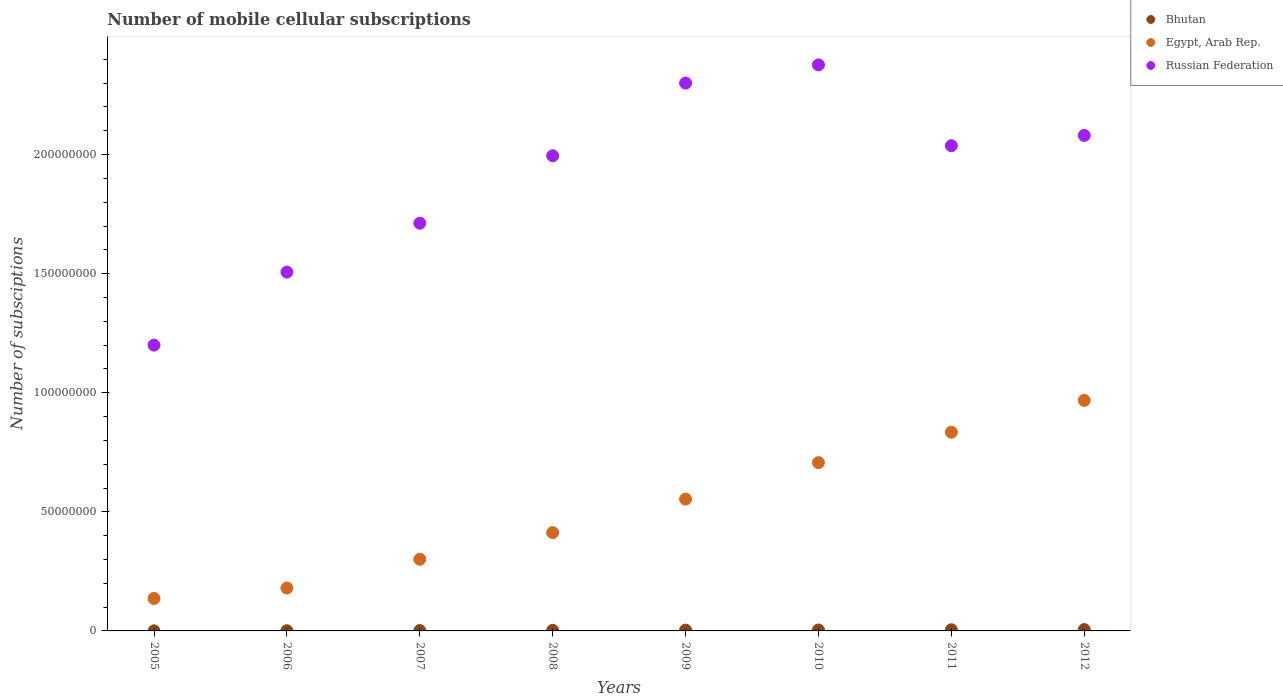Is the number of dotlines equal to the number of legend labels?
Provide a short and direct response. Yes. What is the number of mobile cellular subscriptions in Egypt, Arab Rep. in 2009?
Give a very brief answer. 5.54e+07. Across all years, what is the maximum number of mobile cellular subscriptions in Egypt, Arab Rep.?
Your response must be concise. 9.68e+07. Across all years, what is the minimum number of mobile cellular subscriptions in Bhutan?
Provide a short and direct response. 3.60e+04. In which year was the number of mobile cellular subscriptions in Egypt, Arab Rep. maximum?
Offer a terse response. 2012. In which year was the number of mobile cellular subscriptions in Egypt, Arab Rep. minimum?
Ensure brevity in your answer.  2005. What is the total number of mobile cellular subscriptions in Russian Federation in the graph?
Offer a terse response. 1.52e+09. What is the difference between the number of mobile cellular subscriptions in Russian Federation in 2005 and that in 2011?
Your response must be concise. -8.38e+07. What is the difference between the number of mobile cellular subscriptions in Egypt, Arab Rep. in 2006 and the number of mobile cellular subscriptions in Russian Federation in 2012?
Keep it short and to the point. -1.90e+08. What is the average number of mobile cellular subscriptions in Egypt, Arab Rep. per year?
Make the answer very short. 5.12e+07. In the year 2006, what is the difference between the number of mobile cellular subscriptions in Russian Federation and number of mobile cellular subscriptions in Bhutan?
Offer a terse response. 1.51e+08. What is the ratio of the number of mobile cellular subscriptions in Egypt, Arab Rep. in 2006 to that in 2008?
Your answer should be compact. 0.44. What is the difference between the highest and the second highest number of mobile cellular subscriptions in Russian Federation?
Your answer should be very brief. 7.64e+06. What is the difference between the highest and the lowest number of mobile cellular subscriptions in Russian Federation?
Offer a very short reply. 1.18e+08. Is the number of mobile cellular subscriptions in Egypt, Arab Rep. strictly greater than the number of mobile cellular subscriptions in Russian Federation over the years?
Ensure brevity in your answer.  No. Is the number of mobile cellular subscriptions in Russian Federation strictly less than the number of mobile cellular subscriptions in Egypt, Arab Rep. over the years?
Your answer should be compact. No. How many dotlines are there?
Offer a terse response. 3. What is the difference between two consecutive major ticks on the Y-axis?
Keep it short and to the point. 5.00e+07. Does the graph contain any zero values?
Provide a short and direct response. No. Does the graph contain grids?
Provide a short and direct response. No. Where does the legend appear in the graph?
Ensure brevity in your answer.  Top right. How are the legend labels stacked?
Offer a terse response. Vertical. What is the title of the graph?
Your answer should be very brief. Number of mobile cellular subscriptions. Does "Venezuela" appear as one of the legend labels in the graph?
Make the answer very short. No. What is the label or title of the X-axis?
Your answer should be very brief. Years. What is the label or title of the Y-axis?
Give a very brief answer. Number of subsciptions. What is the Number of subsciptions of Bhutan in 2005?
Offer a very short reply. 3.60e+04. What is the Number of subsciptions of Egypt, Arab Rep. in 2005?
Offer a very short reply. 1.36e+07. What is the Number of subsciptions in Russian Federation in 2005?
Provide a succinct answer. 1.20e+08. What is the Number of subsciptions in Bhutan in 2006?
Offer a terse response. 8.21e+04. What is the Number of subsciptions in Egypt, Arab Rep. in 2006?
Your answer should be very brief. 1.80e+07. What is the Number of subsciptions of Russian Federation in 2006?
Offer a terse response. 1.51e+08. What is the Number of subsciptions in Bhutan in 2007?
Ensure brevity in your answer.  1.49e+05. What is the Number of subsciptions of Egypt, Arab Rep. in 2007?
Your answer should be compact. 3.01e+07. What is the Number of subsciptions of Russian Federation in 2007?
Give a very brief answer. 1.71e+08. What is the Number of subsciptions of Bhutan in 2008?
Give a very brief answer. 2.53e+05. What is the Number of subsciptions of Egypt, Arab Rep. in 2008?
Make the answer very short. 4.13e+07. What is the Number of subsciptions in Russian Federation in 2008?
Keep it short and to the point. 2.00e+08. What is the Number of subsciptions in Bhutan in 2009?
Offer a terse response. 3.39e+05. What is the Number of subsciptions of Egypt, Arab Rep. in 2009?
Your response must be concise. 5.54e+07. What is the Number of subsciptions of Russian Federation in 2009?
Ensure brevity in your answer.  2.30e+08. What is the Number of subsciptions in Bhutan in 2010?
Make the answer very short. 3.94e+05. What is the Number of subsciptions of Egypt, Arab Rep. in 2010?
Offer a terse response. 7.07e+07. What is the Number of subsciptions of Russian Federation in 2010?
Provide a short and direct response. 2.38e+08. What is the Number of subsciptions in Bhutan in 2011?
Ensure brevity in your answer.  4.84e+05. What is the Number of subsciptions in Egypt, Arab Rep. in 2011?
Provide a succinct answer. 8.34e+07. What is the Number of subsciptions in Russian Federation in 2011?
Offer a terse response. 2.04e+08. What is the Number of subsciptions in Bhutan in 2012?
Make the answer very short. 5.61e+05. What is the Number of subsciptions of Egypt, Arab Rep. in 2012?
Offer a very short reply. 9.68e+07. What is the Number of subsciptions in Russian Federation in 2012?
Provide a succinct answer. 2.08e+08. Across all years, what is the maximum Number of subsciptions in Bhutan?
Give a very brief answer. 5.61e+05. Across all years, what is the maximum Number of subsciptions in Egypt, Arab Rep.?
Offer a very short reply. 9.68e+07. Across all years, what is the maximum Number of subsciptions of Russian Federation?
Offer a terse response. 2.38e+08. Across all years, what is the minimum Number of subsciptions of Bhutan?
Give a very brief answer. 3.60e+04. Across all years, what is the minimum Number of subsciptions in Egypt, Arab Rep.?
Keep it short and to the point. 1.36e+07. Across all years, what is the minimum Number of subsciptions in Russian Federation?
Keep it short and to the point. 1.20e+08. What is the total Number of subsciptions in Bhutan in the graph?
Your answer should be very brief. 2.30e+06. What is the total Number of subsciptions in Egypt, Arab Rep. in the graph?
Offer a terse response. 4.09e+08. What is the total Number of subsciptions in Russian Federation in the graph?
Offer a very short reply. 1.52e+09. What is the difference between the Number of subsciptions of Bhutan in 2005 and that in 2006?
Your answer should be very brief. -4.61e+04. What is the difference between the Number of subsciptions in Egypt, Arab Rep. in 2005 and that in 2006?
Offer a very short reply. -4.37e+06. What is the difference between the Number of subsciptions in Russian Federation in 2005 and that in 2006?
Provide a succinct answer. -3.07e+07. What is the difference between the Number of subsciptions of Bhutan in 2005 and that in 2007?
Provide a short and direct response. -1.13e+05. What is the difference between the Number of subsciptions in Egypt, Arab Rep. in 2005 and that in 2007?
Ensure brevity in your answer.  -1.65e+07. What is the difference between the Number of subsciptions of Russian Federation in 2005 and that in 2007?
Keep it short and to the point. -5.12e+07. What is the difference between the Number of subsciptions in Bhutan in 2005 and that in 2008?
Your answer should be compact. -2.17e+05. What is the difference between the Number of subsciptions in Egypt, Arab Rep. in 2005 and that in 2008?
Your answer should be compact. -2.77e+07. What is the difference between the Number of subsciptions in Russian Federation in 2005 and that in 2008?
Provide a short and direct response. -7.95e+07. What is the difference between the Number of subsciptions in Bhutan in 2005 and that in 2009?
Provide a short and direct response. -3.03e+05. What is the difference between the Number of subsciptions of Egypt, Arab Rep. in 2005 and that in 2009?
Provide a succinct answer. -4.17e+07. What is the difference between the Number of subsciptions of Russian Federation in 2005 and that in 2009?
Your response must be concise. -1.10e+08. What is the difference between the Number of subsciptions in Bhutan in 2005 and that in 2010?
Your answer should be compact. -3.58e+05. What is the difference between the Number of subsciptions of Egypt, Arab Rep. in 2005 and that in 2010?
Your response must be concise. -5.70e+07. What is the difference between the Number of subsciptions in Russian Federation in 2005 and that in 2010?
Keep it short and to the point. -1.18e+08. What is the difference between the Number of subsciptions in Bhutan in 2005 and that in 2011?
Provide a short and direct response. -4.48e+05. What is the difference between the Number of subsciptions in Egypt, Arab Rep. in 2005 and that in 2011?
Your answer should be very brief. -6.98e+07. What is the difference between the Number of subsciptions of Russian Federation in 2005 and that in 2011?
Ensure brevity in your answer.  -8.38e+07. What is the difference between the Number of subsciptions of Bhutan in 2005 and that in 2012?
Provide a succinct answer. -5.25e+05. What is the difference between the Number of subsciptions of Egypt, Arab Rep. in 2005 and that in 2012?
Your response must be concise. -8.32e+07. What is the difference between the Number of subsciptions of Russian Federation in 2005 and that in 2012?
Give a very brief answer. -8.81e+07. What is the difference between the Number of subsciptions in Bhutan in 2006 and that in 2007?
Provide a short and direct response. -6.74e+04. What is the difference between the Number of subsciptions in Egypt, Arab Rep. in 2006 and that in 2007?
Make the answer very short. -1.21e+07. What is the difference between the Number of subsciptions of Russian Federation in 2006 and that in 2007?
Provide a short and direct response. -2.05e+07. What is the difference between the Number of subsciptions in Bhutan in 2006 and that in 2008?
Give a very brief answer. -1.71e+05. What is the difference between the Number of subsciptions of Egypt, Arab Rep. in 2006 and that in 2008?
Keep it short and to the point. -2.33e+07. What is the difference between the Number of subsciptions of Russian Federation in 2006 and that in 2008?
Give a very brief answer. -4.88e+07. What is the difference between the Number of subsciptions in Bhutan in 2006 and that in 2009?
Give a very brief answer. -2.57e+05. What is the difference between the Number of subsciptions of Egypt, Arab Rep. in 2006 and that in 2009?
Offer a very short reply. -3.74e+07. What is the difference between the Number of subsciptions in Russian Federation in 2006 and that in 2009?
Your answer should be very brief. -7.94e+07. What is the difference between the Number of subsciptions of Bhutan in 2006 and that in 2010?
Keep it short and to the point. -3.12e+05. What is the difference between the Number of subsciptions of Egypt, Arab Rep. in 2006 and that in 2010?
Offer a terse response. -5.27e+07. What is the difference between the Number of subsciptions in Russian Federation in 2006 and that in 2010?
Keep it short and to the point. -8.70e+07. What is the difference between the Number of subsciptions of Bhutan in 2006 and that in 2011?
Give a very brief answer. -4.02e+05. What is the difference between the Number of subsciptions of Egypt, Arab Rep. in 2006 and that in 2011?
Your answer should be compact. -6.54e+07. What is the difference between the Number of subsciptions in Russian Federation in 2006 and that in 2011?
Ensure brevity in your answer.  -5.31e+07. What is the difference between the Number of subsciptions in Bhutan in 2006 and that in 2012?
Provide a succinct answer. -4.79e+05. What is the difference between the Number of subsciptions of Egypt, Arab Rep. in 2006 and that in 2012?
Your answer should be very brief. -7.88e+07. What is the difference between the Number of subsciptions in Russian Federation in 2006 and that in 2012?
Provide a succinct answer. -5.74e+07. What is the difference between the Number of subsciptions in Bhutan in 2007 and that in 2008?
Make the answer very short. -1.04e+05. What is the difference between the Number of subsciptions of Egypt, Arab Rep. in 2007 and that in 2008?
Make the answer very short. -1.12e+07. What is the difference between the Number of subsciptions in Russian Federation in 2007 and that in 2008?
Your response must be concise. -2.83e+07. What is the difference between the Number of subsciptions of Bhutan in 2007 and that in 2009?
Offer a very short reply. -1.89e+05. What is the difference between the Number of subsciptions of Egypt, Arab Rep. in 2007 and that in 2009?
Give a very brief answer. -2.53e+07. What is the difference between the Number of subsciptions in Russian Federation in 2007 and that in 2009?
Provide a short and direct response. -5.88e+07. What is the difference between the Number of subsciptions of Bhutan in 2007 and that in 2010?
Provide a succinct answer. -2.45e+05. What is the difference between the Number of subsciptions of Egypt, Arab Rep. in 2007 and that in 2010?
Your answer should be compact. -4.06e+07. What is the difference between the Number of subsciptions of Russian Federation in 2007 and that in 2010?
Offer a terse response. -6.65e+07. What is the difference between the Number of subsciptions of Bhutan in 2007 and that in 2011?
Offer a terse response. -3.35e+05. What is the difference between the Number of subsciptions in Egypt, Arab Rep. in 2007 and that in 2011?
Offer a terse response. -5.33e+07. What is the difference between the Number of subsciptions of Russian Federation in 2007 and that in 2011?
Your answer should be very brief. -3.26e+07. What is the difference between the Number of subsciptions in Bhutan in 2007 and that in 2012?
Provide a short and direct response. -4.11e+05. What is the difference between the Number of subsciptions of Egypt, Arab Rep. in 2007 and that in 2012?
Give a very brief answer. -6.67e+07. What is the difference between the Number of subsciptions of Russian Federation in 2007 and that in 2012?
Keep it short and to the point. -3.69e+07. What is the difference between the Number of subsciptions of Bhutan in 2008 and that in 2009?
Make the answer very short. -8.55e+04. What is the difference between the Number of subsciptions in Egypt, Arab Rep. in 2008 and that in 2009?
Ensure brevity in your answer.  -1.41e+07. What is the difference between the Number of subsciptions of Russian Federation in 2008 and that in 2009?
Offer a terse response. -3.05e+07. What is the difference between the Number of subsciptions of Bhutan in 2008 and that in 2010?
Ensure brevity in your answer.  -1.41e+05. What is the difference between the Number of subsciptions in Egypt, Arab Rep. in 2008 and that in 2010?
Make the answer very short. -2.94e+07. What is the difference between the Number of subsciptions in Russian Federation in 2008 and that in 2010?
Offer a terse response. -3.82e+07. What is the difference between the Number of subsciptions in Bhutan in 2008 and that in 2011?
Make the answer very short. -2.31e+05. What is the difference between the Number of subsciptions in Egypt, Arab Rep. in 2008 and that in 2011?
Make the answer very short. -4.21e+07. What is the difference between the Number of subsciptions of Russian Federation in 2008 and that in 2011?
Offer a terse response. -4.23e+06. What is the difference between the Number of subsciptions in Bhutan in 2008 and that in 2012?
Your response must be concise. -3.07e+05. What is the difference between the Number of subsciptions of Egypt, Arab Rep. in 2008 and that in 2012?
Provide a succinct answer. -5.55e+07. What is the difference between the Number of subsciptions in Russian Federation in 2008 and that in 2012?
Ensure brevity in your answer.  -8.54e+06. What is the difference between the Number of subsciptions of Bhutan in 2009 and that in 2010?
Offer a terse response. -5.54e+04. What is the difference between the Number of subsciptions of Egypt, Arab Rep. in 2009 and that in 2010?
Ensure brevity in your answer.  -1.53e+07. What is the difference between the Number of subsciptions in Russian Federation in 2009 and that in 2010?
Ensure brevity in your answer.  -7.64e+06. What is the difference between the Number of subsciptions of Bhutan in 2009 and that in 2011?
Keep it short and to the point. -1.45e+05. What is the difference between the Number of subsciptions of Egypt, Arab Rep. in 2009 and that in 2011?
Provide a succinct answer. -2.81e+07. What is the difference between the Number of subsciptions of Russian Federation in 2009 and that in 2011?
Your answer should be compact. 2.63e+07. What is the difference between the Number of subsciptions of Bhutan in 2009 and that in 2012?
Give a very brief answer. -2.22e+05. What is the difference between the Number of subsciptions in Egypt, Arab Rep. in 2009 and that in 2012?
Your answer should be very brief. -4.14e+07. What is the difference between the Number of subsciptions of Russian Federation in 2009 and that in 2012?
Your answer should be very brief. 2.20e+07. What is the difference between the Number of subsciptions of Bhutan in 2010 and that in 2011?
Give a very brief answer. -8.99e+04. What is the difference between the Number of subsciptions of Egypt, Arab Rep. in 2010 and that in 2011?
Your answer should be compact. -1.28e+07. What is the difference between the Number of subsciptions in Russian Federation in 2010 and that in 2011?
Your response must be concise. 3.39e+07. What is the difference between the Number of subsciptions of Bhutan in 2010 and that in 2012?
Your answer should be very brief. -1.67e+05. What is the difference between the Number of subsciptions in Egypt, Arab Rep. in 2010 and that in 2012?
Offer a very short reply. -2.61e+07. What is the difference between the Number of subsciptions of Russian Federation in 2010 and that in 2012?
Keep it short and to the point. 2.96e+07. What is the difference between the Number of subsciptions in Bhutan in 2011 and that in 2012?
Keep it short and to the point. -7.67e+04. What is the difference between the Number of subsciptions of Egypt, Arab Rep. in 2011 and that in 2012?
Your answer should be very brief. -1.34e+07. What is the difference between the Number of subsciptions of Russian Federation in 2011 and that in 2012?
Provide a short and direct response. -4.31e+06. What is the difference between the Number of subsciptions of Bhutan in 2005 and the Number of subsciptions of Egypt, Arab Rep. in 2006?
Provide a succinct answer. -1.80e+07. What is the difference between the Number of subsciptions of Bhutan in 2005 and the Number of subsciptions of Russian Federation in 2006?
Give a very brief answer. -1.51e+08. What is the difference between the Number of subsciptions of Egypt, Arab Rep. in 2005 and the Number of subsciptions of Russian Federation in 2006?
Offer a terse response. -1.37e+08. What is the difference between the Number of subsciptions in Bhutan in 2005 and the Number of subsciptions in Egypt, Arab Rep. in 2007?
Make the answer very short. -3.01e+07. What is the difference between the Number of subsciptions of Bhutan in 2005 and the Number of subsciptions of Russian Federation in 2007?
Ensure brevity in your answer.  -1.71e+08. What is the difference between the Number of subsciptions in Egypt, Arab Rep. in 2005 and the Number of subsciptions in Russian Federation in 2007?
Your answer should be compact. -1.58e+08. What is the difference between the Number of subsciptions in Bhutan in 2005 and the Number of subsciptions in Egypt, Arab Rep. in 2008?
Provide a succinct answer. -4.13e+07. What is the difference between the Number of subsciptions of Bhutan in 2005 and the Number of subsciptions of Russian Federation in 2008?
Your answer should be compact. -1.99e+08. What is the difference between the Number of subsciptions of Egypt, Arab Rep. in 2005 and the Number of subsciptions of Russian Federation in 2008?
Provide a succinct answer. -1.86e+08. What is the difference between the Number of subsciptions of Bhutan in 2005 and the Number of subsciptions of Egypt, Arab Rep. in 2009?
Provide a succinct answer. -5.53e+07. What is the difference between the Number of subsciptions of Bhutan in 2005 and the Number of subsciptions of Russian Federation in 2009?
Ensure brevity in your answer.  -2.30e+08. What is the difference between the Number of subsciptions in Egypt, Arab Rep. in 2005 and the Number of subsciptions in Russian Federation in 2009?
Your answer should be very brief. -2.16e+08. What is the difference between the Number of subsciptions of Bhutan in 2005 and the Number of subsciptions of Egypt, Arab Rep. in 2010?
Your answer should be compact. -7.06e+07. What is the difference between the Number of subsciptions of Bhutan in 2005 and the Number of subsciptions of Russian Federation in 2010?
Ensure brevity in your answer.  -2.38e+08. What is the difference between the Number of subsciptions in Egypt, Arab Rep. in 2005 and the Number of subsciptions in Russian Federation in 2010?
Make the answer very short. -2.24e+08. What is the difference between the Number of subsciptions of Bhutan in 2005 and the Number of subsciptions of Egypt, Arab Rep. in 2011?
Your answer should be very brief. -8.34e+07. What is the difference between the Number of subsciptions in Bhutan in 2005 and the Number of subsciptions in Russian Federation in 2011?
Ensure brevity in your answer.  -2.04e+08. What is the difference between the Number of subsciptions of Egypt, Arab Rep. in 2005 and the Number of subsciptions of Russian Federation in 2011?
Your response must be concise. -1.90e+08. What is the difference between the Number of subsciptions in Bhutan in 2005 and the Number of subsciptions in Egypt, Arab Rep. in 2012?
Offer a very short reply. -9.68e+07. What is the difference between the Number of subsciptions of Bhutan in 2005 and the Number of subsciptions of Russian Federation in 2012?
Ensure brevity in your answer.  -2.08e+08. What is the difference between the Number of subsciptions of Egypt, Arab Rep. in 2005 and the Number of subsciptions of Russian Federation in 2012?
Your response must be concise. -1.94e+08. What is the difference between the Number of subsciptions of Bhutan in 2006 and the Number of subsciptions of Egypt, Arab Rep. in 2007?
Make the answer very short. -3.00e+07. What is the difference between the Number of subsciptions in Bhutan in 2006 and the Number of subsciptions in Russian Federation in 2007?
Your answer should be compact. -1.71e+08. What is the difference between the Number of subsciptions of Egypt, Arab Rep. in 2006 and the Number of subsciptions of Russian Federation in 2007?
Ensure brevity in your answer.  -1.53e+08. What is the difference between the Number of subsciptions in Bhutan in 2006 and the Number of subsciptions in Egypt, Arab Rep. in 2008?
Provide a succinct answer. -4.12e+07. What is the difference between the Number of subsciptions in Bhutan in 2006 and the Number of subsciptions in Russian Federation in 2008?
Your response must be concise. -1.99e+08. What is the difference between the Number of subsciptions of Egypt, Arab Rep. in 2006 and the Number of subsciptions of Russian Federation in 2008?
Offer a terse response. -1.82e+08. What is the difference between the Number of subsciptions of Bhutan in 2006 and the Number of subsciptions of Egypt, Arab Rep. in 2009?
Your answer should be compact. -5.53e+07. What is the difference between the Number of subsciptions in Bhutan in 2006 and the Number of subsciptions in Russian Federation in 2009?
Provide a short and direct response. -2.30e+08. What is the difference between the Number of subsciptions in Egypt, Arab Rep. in 2006 and the Number of subsciptions in Russian Federation in 2009?
Make the answer very short. -2.12e+08. What is the difference between the Number of subsciptions of Bhutan in 2006 and the Number of subsciptions of Egypt, Arab Rep. in 2010?
Keep it short and to the point. -7.06e+07. What is the difference between the Number of subsciptions of Bhutan in 2006 and the Number of subsciptions of Russian Federation in 2010?
Offer a terse response. -2.38e+08. What is the difference between the Number of subsciptions of Egypt, Arab Rep. in 2006 and the Number of subsciptions of Russian Federation in 2010?
Provide a short and direct response. -2.20e+08. What is the difference between the Number of subsciptions of Bhutan in 2006 and the Number of subsciptions of Egypt, Arab Rep. in 2011?
Your answer should be compact. -8.33e+07. What is the difference between the Number of subsciptions in Bhutan in 2006 and the Number of subsciptions in Russian Federation in 2011?
Offer a terse response. -2.04e+08. What is the difference between the Number of subsciptions in Egypt, Arab Rep. in 2006 and the Number of subsciptions in Russian Federation in 2011?
Your answer should be very brief. -1.86e+08. What is the difference between the Number of subsciptions of Bhutan in 2006 and the Number of subsciptions of Egypt, Arab Rep. in 2012?
Your response must be concise. -9.67e+07. What is the difference between the Number of subsciptions of Bhutan in 2006 and the Number of subsciptions of Russian Federation in 2012?
Offer a very short reply. -2.08e+08. What is the difference between the Number of subsciptions in Egypt, Arab Rep. in 2006 and the Number of subsciptions in Russian Federation in 2012?
Offer a terse response. -1.90e+08. What is the difference between the Number of subsciptions of Bhutan in 2007 and the Number of subsciptions of Egypt, Arab Rep. in 2008?
Provide a succinct answer. -4.11e+07. What is the difference between the Number of subsciptions in Bhutan in 2007 and the Number of subsciptions in Russian Federation in 2008?
Make the answer very short. -1.99e+08. What is the difference between the Number of subsciptions in Egypt, Arab Rep. in 2007 and the Number of subsciptions in Russian Federation in 2008?
Provide a succinct answer. -1.69e+08. What is the difference between the Number of subsciptions of Bhutan in 2007 and the Number of subsciptions of Egypt, Arab Rep. in 2009?
Offer a very short reply. -5.52e+07. What is the difference between the Number of subsciptions in Bhutan in 2007 and the Number of subsciptions in Russian Federation in 2009?
Give a very brief answer. -2.30e+08. What is the difference between the Number of subsciptions of Egypt, Arab Rep. in 2007 and the Number of subsciptions of Russian Federation in 2009?
Provide a short and direct response. -2.00e+08. What is the difference between the Number of subsciptions in Bhutan in 2007 and the Number of subsciptions in Egypt, Arab Rep. in 2010?
Ensure brevity in your answer.  -7.05e+07. What is the difference between the Number of subsciptions in Bhutan in 2007 and the Number of subsciptions in Russian Federation in 2010?
Give a very brief answer. -2.38e+08. What is the difference between the Number of subsciptions in Egypt, Arab Rep. in 2007 and the Number of subsciptions in Russian Federation in 2010?
Give a very brief answer. -2.08e+08. What is the difference between the Number of subsciptions of Bhutan in 2007 and the Number of subsciptions of Egypt, Arab Rep. in 2011?
Your answer should be very brief. -8.33e+07. What is the difference between the Number of subsciptions in Bhutan in 2007 and the Number of subsciptions in Russian Federation in 2011?
Provide a succinct answer. -2.04e+08. What is the difference between the Number of subsciptions in Egypt, Arab Rep. in 2007 and the Number of subsciptions in Russian Federation in 2011?
Offer a very short reply. -1.74e+08. What is the difference between the Number of subsciptions of Bhutan in 2007 and the Number of subsciptions of Egypt, Arab Rep. in 2012?
Offer a very short reply. -9.66e+07. What is the difference between the Number of subsciptions in Bhutan in 2007 and the Number of subsciptions in Russian Federation in 2012?
Give a very brief answer. -2.08e+08. What is the difference between the Number of subsciptions in Egypt, Arab Rep. in 2007 and the Number of subsciptions in Russian Federation in 2012?
Provide a succinct answer. -1.78e+08. What is the difference between the Number of subsciptions in Bhutan in 2008 and the Number of subsciptions in Egypt, Arab Rep. in 2009?
Keep it short and to the point. -5.51e+07. What is the difference between the Number of subsciptions in Bhutan in 2008 and the Number of subsciptions in Russian Federation in 2009?
Offer a terse response. -2.30e+08. What is the difference between the Number of subsciptions of Egypt, Arab Rep. in 2008 and the Number of subsciptions of Russian Federation in 2009?
Keep it short and to the point. -1.89e+08. What is the difference between the Number of subsciptions in Bhutan in 2008 and the Number of subsciptions in Egypt, Arab Rep. in 2010?
Offer a terse response. -7.04e+07. What is the difference between the Number of subsciptions in Bhutan in 2008 and the Number of subsciptions in Russian Federation in 2010?
Provide a succinct answer. -2.37e+08. What is the difference between the Number of subsciptions of Egypt, Arab Rep. in 2008 and the Number of subsciptions of Russian Federation in 2010?
Ensure brevity in your answer.  -1.96e+08. What is the difference between the Number of subsciptions of Bhutan in 2008 and the Number of subsciptions of Egypt, Arab Rep. in 2011?
Keep it short and to the point. -8.32e+07. What is the difference between the Number of subsciptions of Bhutan in 2008 and the Number of subsciptions of Russian Federation in 2011?
Ensure brevity in your answer.  -2.03e+08. What is the difference between the Number of subsciptions of Egypt, Arab Rep. in 2008 and the Number of subsciptions of Russian Federation in 2011?
Offer a terse response. -1.62e+08. What is the difference between the Number of subsciptions in Bhutan in 2008 and the Number of subsciptions in Egypt, Arab Rep. in 2012?
Your response must be concise. -9.65e+07. What is the difference between the Number of subsciptions in Bhutan in 2008 and the Number of subsciptions in Russian Federation in 2012?
Make the answer very short. -2.08e+08. What is the difference between the Number of subsciptions of Egypt, Arab Rep. in 2008 and the Number of subsciptions of Russian Federation in 2012?
Provide a short and direct response. -1.67e+08. What is the difference between the Number of subsciptions in Bhutan in 2009 and the Number of subsciptions in Egypt, Arab Rep. in 2010?
Ensure brevity in your answer.  -7.03e+07. What is the difference between the Number of subsciptions of Bhutan in 2009 and the Number of subsciptions of Russian Federation in 2010?
Ensure brevity in your answer.  -2.37e+08. What is the difference between the Number of subsciptions in Egypt, Arab Rep. in 2009 and the Number of subsciptions in Russian Federation in 2010?
Offer a terse response. -1.82e+08. What is the difference between the Number of subsciptions of Bhutan in 2009 and the Number of subsciptions of Egypt, Arab Rep. in 2011?
Your response must be concise. -8.31e+07. What is the difference between the Number of subsciptions of Bhutan in 2009 and the Number of subsciptions of Russian Federation in 2011?
Your answer should be very brief. -2.03e+08. What is the difference between the Number of subsciptions in Egypt, Arab Rep. in 2009 and the Number of subsciptions in Russian Federation in 2011?
Your answer should be compact. -1.48e+08. What is the difference between the Number of subsciptions of Bhutan in 2009 and the Number of subsciptions of Egypt, Arab Rep. in 2012?
Your response must be concise. -9.65e+07. What is the difference between the Number of subsciptions in Bhutan in 2009 and the Number of subsciptions in Russian Federation in 2012?
Give a very brief answer. -2.08e+08. What is the difference between the Number of subsciptions in Egypt, Arab Rep. in 2009 and the Number of subsciptions in Russian Federation in 2012?
Make the answer very short. -1.53e+08. What is the difference between the Number of subsciptions in Bhutan in 2010 and the Number of subsciptions in Egypt, Arab Rep. in 2011?
Your answer should be compact. -8.30e+07. What is the difference between the Number of subsciptions in Bhutan in 2010 and the Number of subsciptions in Russian Federation in 2011?
Keep it short and to the point. -2.03e+08. What is the difference between the Number of subsciptions of Egypt, Arab Rep. in 2010 and the Number of subsciptions of Russian Federation in 2011?
Provide a succinct answer. -1.33e+08. What is the difference between the Number of subsciptions of Bhutan in 2010 and the Number of subsciptions of Egypt, Arab Rep. in 2012?
Your answer should be compact. -9.64e+07. What is the difference between the Number of subsciptions of Bhutan in 2010 and the Number of subsciptions of Russian Federation in 2012?
Keep it short and to the point. -2.08e+08. What is the difference between the Number of subsciptions of Egypt, Arab Rep. in 2010 and the Number of subsciptions of Russian Federation in 2012?
Give a very brief answer. -1.37e+08. What is the difference between the Number of subsciptions in Bhutan in 2011 and the Number of subsciptions in Egypt, Arab Rep. in 2012?
Make the answer very short. -9.63e+07. What is the difference between the Number of subsciptions of Bhutan in 2011 and the Number of subsciptions of Russian Federation in 2012?
Offer a very short reply. -2.08e+08. What is the difference between the Number of subsciptions in Egypt, Arab Rep. in 2011 and the Number of subsciptions in Russian Federation in 2012?
Make the answer very short. -1.25e+08. What is the average Number of subsciptions of Bhutan per year?
Keep it short and to the point. 2.87e+05. What is the average Number of subsciptions of Egypt, Arab Rep. per year?
Ensure brevity in your answer.  5.12e+07. What is the average Number of subsciptions in Russian Federation per year?
Offer a terse response. 1.90e+08. In the year 2005, what is the difference between the Number of subsciptions of Bhutan and Number of subsciptions of Egypt, Arab Rep.?
Provide a succinct answer. -1.36e+07. In the year 2005, what is the difference between the Number of subsciptions in Bhutan and Number of subsciptions in Russian Federation?
Your answer should be compact. -1.20e+08. In the year 2005, what is the difference between the Number of subsciptions of Egypt, Arab Rep. and Number of subsciptions of Russian Federation?
Ensure brevity in your answer.  -1.06e+08. In the year 2006, what is the difference between the Number of subsciptions of Bhutan and Number of subsciptions of Egypt, Arab Rep.?
Provide a short and direct response. -1.79e+07. In the year 2006, what is the difference between the Number of subsciptions of Bhutan and Number of subsciptions of Russian Federation?
Offer a very short reply. -1.51e+08. In the year 2006, what is the difference between the Number of subsciptions in Egypt, Arab Rep. and Number of subsciptions in Russian Federation?
Your response must be concise. -1.33e+08. In the year 2007, what is the difference between the Number of subsciptions of Bhutan and Number of subsciptions of Egypt, Arab Rep.?
Your response must be concise. -2.99e+07. In the year 2007, what is the difference between the Number of subsciptions of Bhutan and Number of subsciptions of Russian Federation?
Your answer should be compact. -1.71e+08. In the year 2007, what is the difference between the Number of subsciptions in Egypt, Arab Rep. and Number of subsciptions in Russian Federation?
Make the answer very short. -1.41e+08. In the year 2008, what is the difference between the Number of subsciptions of Bhutan and Number of subsciptions of Egypt, Arab Rep.?
Offer a very short reply. -4.10e+07. In the year 2008, what is the difference between the Number of subsciptions in Bhutan and Number of subsciptions in Russian Federation?
Your response must be concise. -1.99e+08. In the year 2008, what is the difference between the Number of subsciptions of Egypt, Arab Rep. and Number of subsciptions of Russian Federation?
Your response must be concise. -1.58e+08. In the year 2009, what is the difference between the Number of subsciptions of Bhutan and Number of subsciptions of Egypt, Arab Rep.?
Your answer should be very brief. -5.50e+07. In the year 2009, what is the difference between the Number of subsciptions of Bhutan and Number of subsciptions of Russian Federation?
Your response must be concise. -2.30e+08. In the year 2009, what is the difference between the Number of subsciptions in Egypt, Arab Rep. and Number of subsciptions in Russian Federation?
Offer a terse response. -1.75e+08. In the year 2010, what is the difference between the Number of subsciptions of Bhutan and Number of subsciptions of Egypt, Arab Rep.?
Offer a very short reply. -7.03e+07. In the year 2010, what is the difference between the Number of subsciptions in Bhutan and Number of subsciptions in Russian Federation?
Make the answer very short. -2.37e+08. In the year 2010, what is the difference between the Number of subsciptions in Egypt, Arab Rep. and Number of subsciptions in Russian Federation?
Your answer should be compact. -1.67e+08. In the year 2011, what is the difference between the Number of subsciptions of Bhutan and Number of subsciptions of Egypt, Arab Rep.?
Provide a short and direct response. -8.29e+07. In the year 2011, what is the difference between the Number of subsciptions of Bhutan and Number of subsciptions of Russian Federation?
Keep it short and to the point. -2.03e+08. In the year 2011, what is the difference between the Number of subsciptions of Egypt, Arab Rep. and Number of subsciptions of Russian Federation?
Ensure brevity in your answer.  -1.20e+08. In the year 2012, what is the difference between the Number of subsciptions of Bhutan and Number of subsciptions of Egypt, Arab Rep.?
Offer a terse response. -9.62e+07. In the year 2012, what is the difference between the Number of subsciptions in Bhutan and Number of subsciptions in Russian Federation?
Your answer should be compact. -2.08e+08. In the year 2012, what is the difference between the Number of subsciptions of Egypt, Arab Rep. and Number of subsciptions of Russian Federation?
Provide a short and direct response. -1.11e+08. What is the ratio of the Number of subsciptions of Bhutan in 2005 to that in 2006?
Offer a terse response. 0.44. What is the ratio of the Number of subsciptions of Egypt, Arab Rep. in 2005 to that in 2006?
Offer a terse response. 0.76. What is the ratio of the Number of subsciptions of Russian Federation in 2005 to that in 2006?
Offer a terse response. 0.8. What is the ratio of the Number of subsciptions in Bhutan in 2005 to that in 2007?
Offer a terse response. 0.24. What is the ratio of the Number of subsciptions of Egypt, Arab Rep. in 2005 to that in 2007?
Your answer should be very brief. 0.45. What is the ratio of the Number of subsciptions of Russian Federation in 2005 to that in 2007?
Your answer should be compact. 0.7. What is the ratio of the Number of subsciptions of Bhutan in 2005 to that in 2008?
Your response must be concise. 0.14. What is the ratio of the Number of subsciptions in Egypt, Arab Rep. in 2005 to that in 2008?
Make the answer very short. 0.33. What is the ratio of the Number of subsciptions in Russian Federation in 2005 to that in 2008?
Your response must be concise. 0.6. What is the ratio of the Number of subsciptions of Bhutan in 2005 to that in 2009?
Give a very brief answer. 0.11. What is the ratio of the Number of subsciptions in Egypt, Arab Rep. in 2005 to that in 2009?
Give a very brief answer. 0.25. What is the ratio of the Number of subsciptions of Russian Federation in 2005 to that in 2009?
Your response must be concise. 0.52. What is the ratio of the Number of subsciptions of Bhutan in 2005 to that in 2010?
Give a very brief answer. 0.09. What is the ratio of the Number of subsciptions in Egypt, Arab Rep. in 2005 to that in 2010?
Give a very brief answer. 0.19. What is the ratio of the Number of subsciptions of Russian Federation in 2005 to that in 2010?
Give a very brief answer. 0.5. What is the ratio of the Number of subsciptions of Bhutan in 2005 to that in 2011?
Offer a terse response. 0.07. What is the ratio of the Number of subsciptions of Egypt, Arab Rep. in 2005 to that in 2011?
Provide a succinct answer. 0.16. What is the ratio of the Number of subsciptions in Russian Federation in 2005 to that in 2011?
Your answer should be compact. 0.59. What is the ratio of the Number of subsciptions of Bhutan in 2005 to that in 2012?
Provide a short and direct response. 0.06. What is the ratio of the Number of subsciptions in Egypt, Arab Rep. in 2005 to that in 2012?
Offer a very short reply. 0.14. What is the ratio of the Number of subsciptions in Russian Federation in 2005 to that in 2012?
Offer a terse response. 0.58. What is the ratio of the Number of subsciptions of Bhutan in 2006 to that in 2007?
Offer a terse response. 0.55. What is the ratio of the Number of subsciptions in Egypt, Arab Rep. in 2006 to that in 2007?
Make the answer very short. 0.6. What is the ratio of the Number of subsciptions in Russian Federation in 2006 to that in 2007?
Keep it short and to the point. 0.88. What is the ratio of the Number of subsciptions of Bhutan in 2006 to that in 2008?
Your answer should be very brief. 0.32. What is the ratio of the Number of subsciptions of Egypt, Arab Rep. in 2006 to that in 2008?
Ensure brevity in your answer.  0.44. What is the ratio of the Number of subsciptions of Russian Federation in 2006 to that in 2008?
Offer a terse response. 0.76. What is the ratio of the Number of subsciptions of Bhutan in 2006 to that in 2009?
Give a very brief answer. 0.24. What is the ratio of the Number of subsciptions in Egypt, Arab Rep. in 2006 to that in 2009?
Ensure brevity in your answer.  0.33. What is the ratio of the Number of subsciptions in Russian Federation in 2006 to that in 2009?
Make the answer very short. 0.66. What is the ratio of the Number of subsciptions in Bhutan in 2006 to that in 2010?
Give a very brief answer. 0.21. What is the ratio of the Number of subsciptions of Egypt, Arab Rep. in 2006 to that in 2010?
Offer a terse response. 0.25. What is the ratio of the Number of subsciptions in Russian Federation in 2006 to that in 2010?
Provide a short and direct response. 0.63. What is the ratio of the Number of subsciptions of Bhutan in 2006 to that in 2011?
Provide a succinct answer. 0.17. What is the ratio of the Number of subsciptions in Egypt, Arab Rep. in 2006 to that in 2011?
Make the answer very short. 0.22. What is the ratio of the Number of subsciptions of Russian Federation in 2006 to that in 2011?
Your response must be concise. 0.74. What is the ratio of the Number of subsciptions of Bhutan in 2006 to that in 2012?
Your answer should be compact. 0.15. What is the ratio of the Number of subsciptions in Egypt, Arab Rep. in 2006 to that in 2012?
Your response must be concise. 0.19. What is the ratio of the Number of subsciptions in Russian Federation in 2006 to that in 2012?
Your answer should be compact. 0.72. What is the ratio of the Number of subsciptions in Bhutan in 2007 to that in 2008?
Offer a very short reply. 0.59. What is the ratio of the Number of subsciptions of Egypt, Arab Rep. in 2007 to that in 2008?
Offer a terse response. 0.73. What is the ratio of the Number of subsciptions of Russian Federation in 2007 to that in 2008?
Make the answer very short. 0.86. What is the ratio of the Number of subsciptions of Bhutan in 2007 to that in 2009?
Make the answer very short. 0.44. What is the ratio of the Number of subsciptions of Egypt, Arab Rep. in 2007 to that in 2009?
Make the answer very short. 0.54. What is the ratio of the Number of subsciptions of Russian Federation in 2007 to that in 2009?
Provide a succinct answer. 0.74. What is the ratio of the Number of subsciptions in Bhutan in 2007 to that in 2010?
Provide a short and direct response. 0.38. What is the ratio of the Number of subsciptions of Egypt, Arab Rep. in 2007 to that in 2010?
Offer a terse response. 0.43. What is the ratio of the Number of subsciptions of Russian Federation in 2007 to that in 2010?
Offer a very short reply. 0.72. What is the ratio of the Number of subsciptions in Bhutan in 2007 to that in 2011?
Ensure brevity in your answer.  0.31. What is the ratio of the Number of subsciptions of Egypt, Arab Rep. in 2007 to that in 2011?
Offer a terse response. 0.36. What is the ratio of the Number of subsciptions in Russian Federation in 2007 to that in 2011?
Make the answer very short. 0.84. What is the ratio of the Number of subsciptions of Bhutan in 2007 to that in 2012?
Your answer should be very brief. 0.27. What is the ratio of the Number of subsciptions of Egypt, Arab Rep. in 2007 to that in 2012?
Your answer should be very brief. 0.31. What is the ratio of the Number of subsciptions of Russian Federation in 2007 to that in 2012?
Provide a short and direct response. 0.82. What is the ratio of the Number of subsciptions of Bhutan in 2008 to that in 2009?
Your answer should be compact. 0.75. What is the ratio of the Number of subsciptions of Egypt, Arab Rep. in 2008 to that in 2009?
Your answer should be very brief. 0.75. What is the ratio of the Number of subsciptions of Russian Federation in 2008 to that in 2009?
Ensure brevity in your answer.  0.87. What is the ratio of the Number of subsciptions of Bhutan in 2008 to that in 2010?
Your response must be concise. 0.64. What is the ratio of the Number of subsciptions of Egypt, Arab Rep. in 2008 to that in 2010?
Your answer should be compact. 0.58. What is the ratio of the Number of subsciptions of Russian Federation in 2008 to that in 2010?
Give a very brief answer. 0.84. What is the ratio of the Number of subsciptions in Bhutan in 2008 to that in 2011?
Provide a succinct answer. 0.52. What is the ratio of the Number of subsciptions in Egypt, Arab Rep. in 2008 to that in 2011?
Provide a succinct answer. 0.49. What is the ratio of the Number of subsciptions in Russian Federation in 2008 to that in 2011?
Your answer should be compact. 0.98. What is the ratio of the Number of subsciptions of Bhutan in 2008 to that in 2012?
Keep it short and to the point. 0.45. What is the ratio of the Number of subsciptions of Egypt, Arab Rep. in 2008 to that in 2012?
Offer a terse response. 0.43. What is the ratio of the Number of subsciptions of Russian Federation in 2008 to that in 2012?
Offer a terse response. 0.96. What is the ratio of the Number of subsciptions of Bhutan in 2009 to that in 2010?
Give a very brief answer. 0.86. What is the ratio of the Number of subsciptions in Egypt, Arab Rep. in 2009 to that in 2010?
Provide a short and direct response. 0.78. What is the ratio of the Number of subsciptions of Russian Federation in 2009 to that in 2010?
Provide a succinct answer. 0.97. What is the ratio of the Number of subsciptions of Bhutan in 2009 to that in 2011?
Ensure brevity in your answer.  0.7. What is the ratio of the Number of subsciptions in Egypt, Arab Rep. in 2009 to that in 2011?
Offer a terse response. 0.66. What is the ratio of the Number of subsciptions of Russian Federation in 2009 to that in 2011?
Offer a terse response. 1.13. What is the ratio of the Number of subsciptions of Bhutan in 2009 to that in 2012?
Provide a short and direct response. 0.6. What is the ratio of the Number of subsciptions of Egypt, Arab Rep. in 2009 to that in 2012?
Keep it short and to the point. 0.57. What is the ratio of the Number of subsciptions of Russian Federation in 2009 to that in 2012?
Offer a very short reply. 1.11. What is the ratio of the Number of subsciptions of Bhutan in 2010 to that in 2011?
Make the answer very short. 0.81. What is the ratio of the Number of subsciptions in Egypt, Arab Rep. in 2010 to that in 2011?
Give a very brief answer. 0.85. What is the ratio of the Number of subsciptions in Russian Federation in 2010 to that in 2011?
Provide a short and direct response. 1.17. What is the ratio of the Number of subsciptions of Bhutan in 2010 to that in 2012?
Your answer should be compact. 0.7. What is the ratio of the Number of subsciptions in Egypt, Arab Rep. in 2010 to that in 2012?
Offer a terse response. 0.73. What is the ratio of the Number of subsciptions in Russian Federation in 2010 to that in 2012?
Your response must be concise. 1.14. What is the ratio of the Number of subsciptions in Bhutan in 2011 to that in 2012?
Provide a short and direct response. 0.86. What is the ratio of the Number of subsciptions of Egypt, Arab Rep. in 2011 to that in 2012?
Your response must be concise. 0.86. What is the ratio of the Number of subsciptions in Russian Federation in 2011 to that in 2012?
Your answer should be compact. 0.98. What is the difference between the highest and the second highest Number of subsciptions of Bhutan?
Offer a terse response. 7.67e+04. What is the difference between the highest and the second highest Number of subsciptions in Egypt, Arab Rep.?
Keep it short and to the point. 1.34e+07. What is the difference between the highest and the second highest Number of subsciptions in Russian Federation?
Keep it short and to the point. 7.64e+06. What is the difference between the highest and the lowest Number of subsciptions in Bhutan?
Make the answer very short. 5.25e+05. What is the difference between the highest and the lowest Number of subsciptions of Egypt, Arab Rep.?
Make the answer very short. 8.32e+07. What is the difference between the highest and the lowest Number of subsciptions in Russian Federation?
Give a very brief answer. 1.18e+08. 